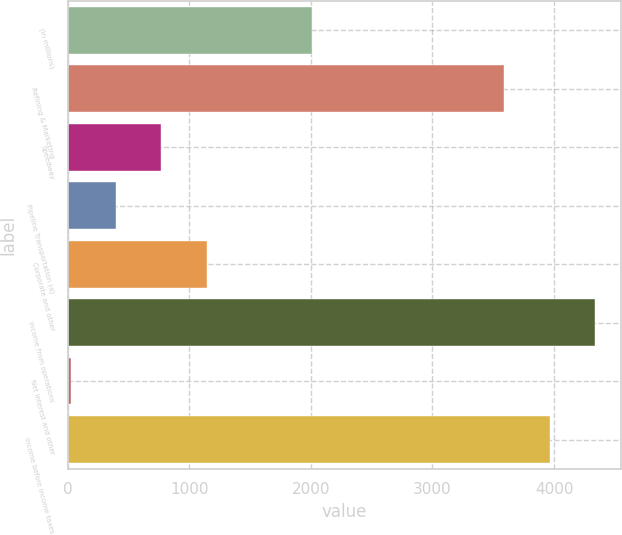Convert chart. <chart><loc_0><loc_0><loc_500><loc_500><bar_chart><fcel>(In millions)<fcel>Refining & Marketing<fcel>Speedway<fcel>Pipeline Transportation (a)<fcel>Corporate and other<fcel>Income from operations<fcel>Net interest and other<fcel>Income before income taxes<nl><fcel>2011<fcel>3591<fcel>769.8<fcel>397.9<fcel>1141.7<fcel>4334.8<fcel>26<fcel>3962.9<nl></chart> 